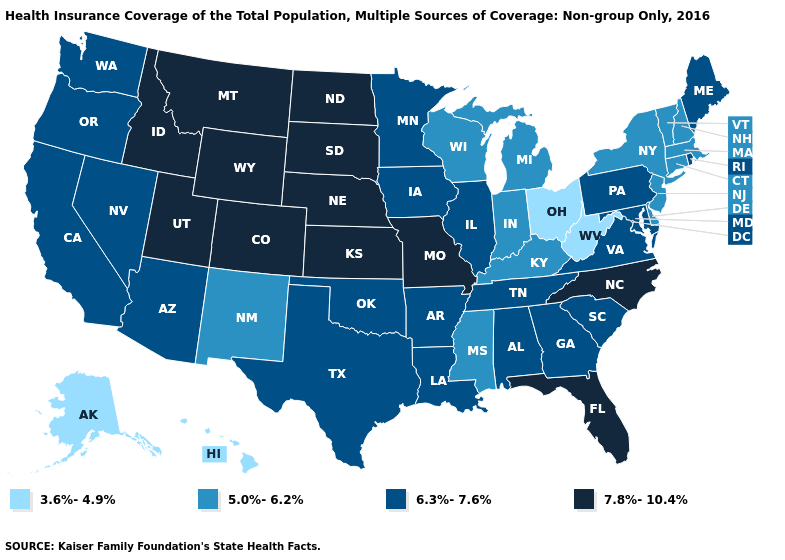Is the legend a continuous bar?
Short answer required. No. What is the value of New Hampshire?
Give a very brief answer. 5.0%-6.2%. What is the value of Iowa?
Write a very short answer. 6.3%-7.6%. Does Arkansas have the highest value in the South?
Short answer required. No. Does Indiana have a higher value than West Virginia?
Quick response, please. Yes. What is the lowest value in states that border New Hampshire?
Write a very short answer. 5.0%-6.2%. Name the states that have a value in the range 6.3%-7.6%?
Quick response, please. Alabama, Arizona, Arkansas, California, Georgia, Illinois, Iowa, Louisiana, Maine, Maryland, Minnesota, Nevada, Oklahoma, Oregon, Pennsylvania, Rhode Island, South Carolina, Tennessee, Texas, Virginia, Washington. What is the value of Hawaii?
Answer briefly. 3.6%-4.9%. Name the states that have a value in the range 3.6%-4.9%?
Quick response, please. Alaska, Hawaii, Ohio, West Virginia. Among the states that border Massachusetts , which have the highest value?
Write a very short answer. Rhode Island. How many symbols are there in the legend?
Short answer required. 4. What is the lowest value in the USA?
Write a very short answer. 3.6%-4.9%. What is the value of Michigan?
Quick response, please. 5.0%-6.2%. Does the map have missing data?
Give a very brief answer. No. 